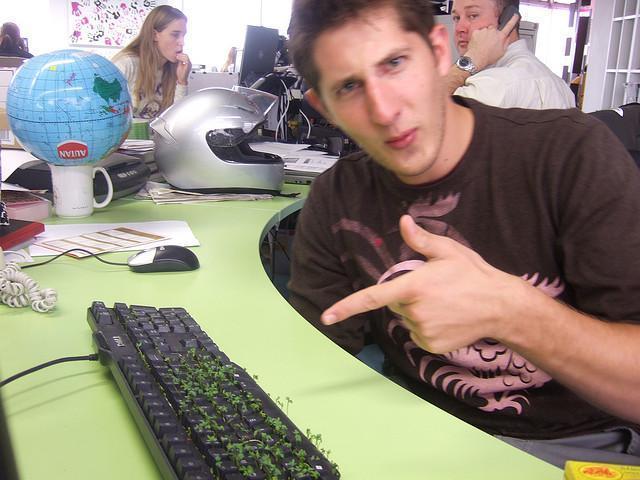How many watches are in the picture?
Give a very brief answer. 1. How many people are there?
Give a very brief answer. 3. 